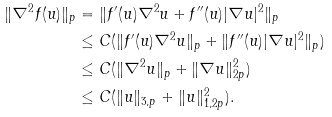<formula> <loc_0><loc_0><loc_500><loc_500>\| \nabla ^ { 2 } f ( u ) \| _ { p } & = \| f ^ { \prime } ( u ) \nabla ^ { 2 } u + f ^ { \prime \prime } ( u ) | \nabla u | ^ { 2 } \| _ { p } \\ & \leq C ( \| f ^ { \prime } ( u ) \nabla ^ { 2 } u \| _ { p } + \| f ^ { \prime \prime } ( u ) | \nabla u | ^ { 2 } \| _ { p } ) \\ & \leq C ( \| \nabla ^ { 2 } u \| _ { p } + \| \nabla u \| _ { 2 p } ^ { 2 } ) \\ & \leq C ( \| u \| _ { 3 , p } + \| u \| _ { 1 , 2 p } ^ { 2 } ) .</formula> 